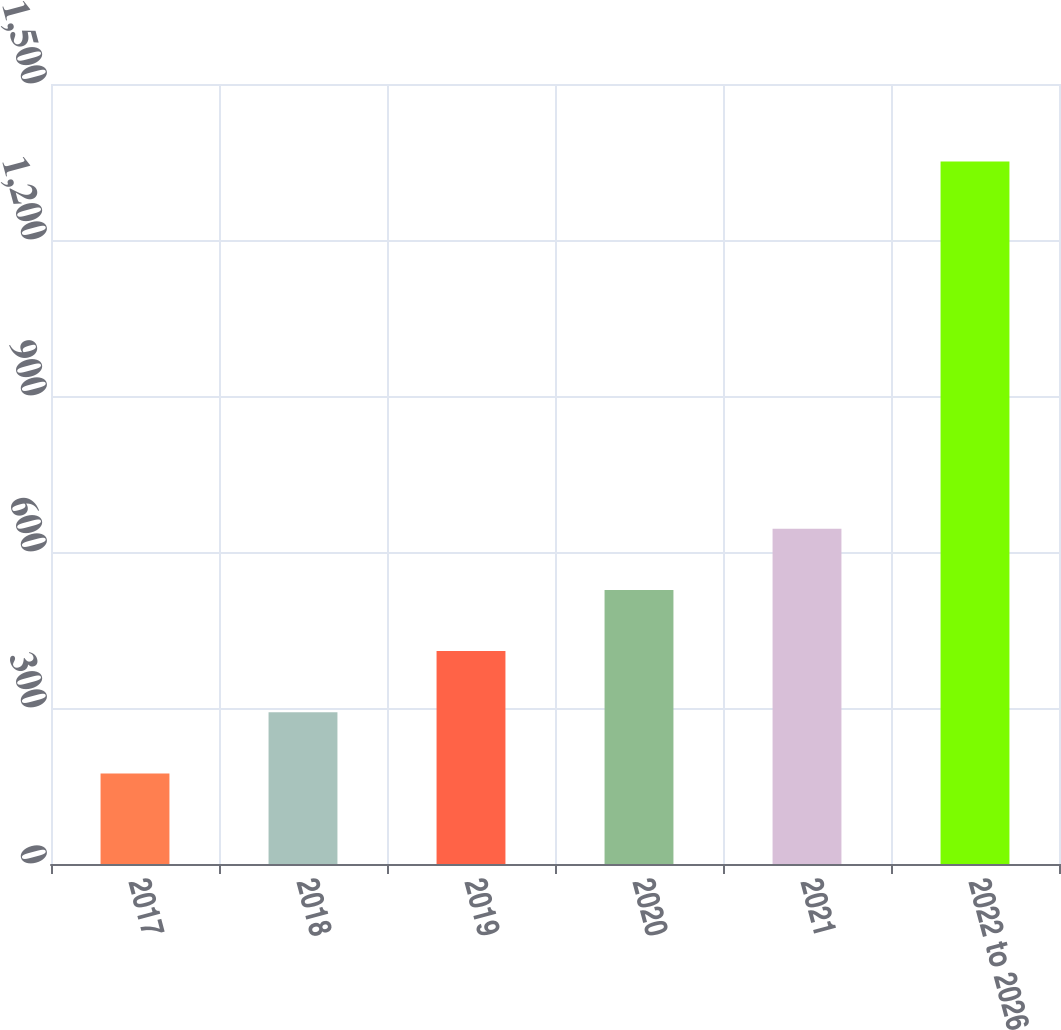<chart> <loc_0><loc_0><loc_500><loc_500><bar_chart><fcel>2017<fcel>2018<fcel>2019<fcel>2020<fcel>2021<fcel>2022 to 2026<nl><fcel>174<fcel>291.7<fcel>409.4<fcel>527.1<fcel>644.8<fcel>1351<nl></chart> 